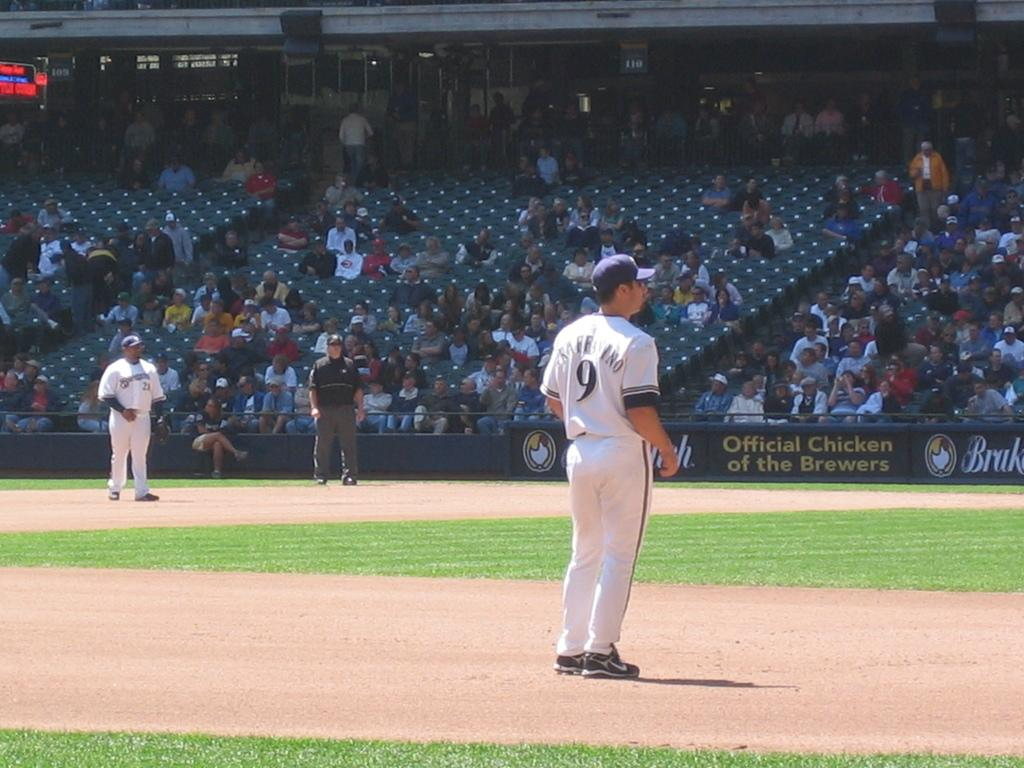<image>
Summarize the visual content of the image. baseball players on a baseball field with a banner for chicken 